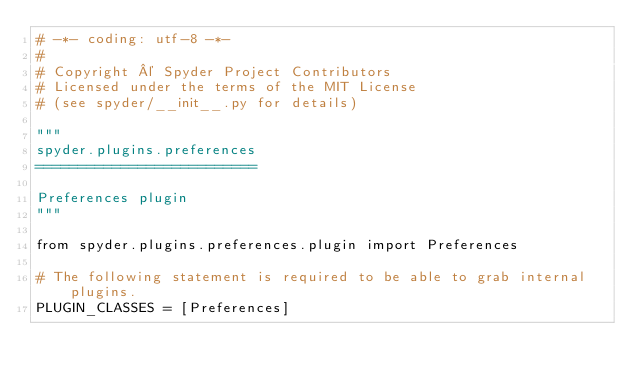<code> <loc_0><loc_0><loc_500><loc_500><_Python_># -*- coding: utf-8 -*-
#
# Copyright © Spyder Project Contributors
# Licensed under the terms of the MIT License
# (see spyder/__init__.py for details)

"""
spyder.plugins.preferences
==========================

Preferences plugin
"""

from spyder.plugins.preferences.plugin import Preferences

# The following statement is required to be able to grab internal plugins.
PLUGIN_CLASSES = [Preferences]
</code> 